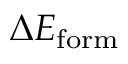<formula> <loc_0><loc_0><loc_500><loc_500>\Delta E _ { f o r m }</formula> 